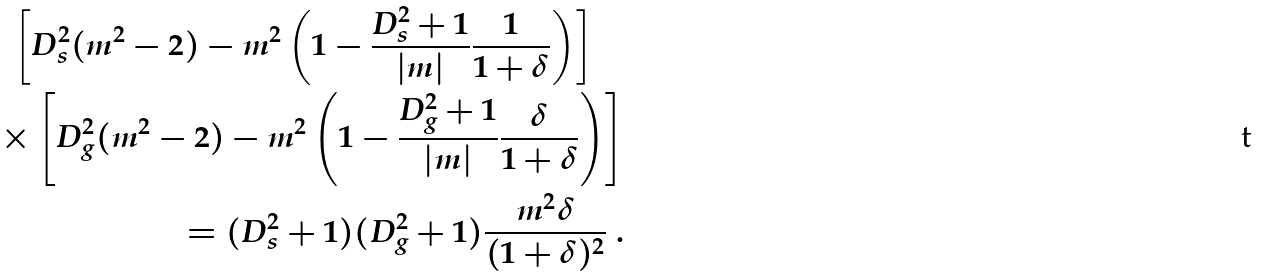<formula> <loc_0><loc_0><loc_500><loc_500>\left [ D _ { s } ^ { 2 } ( m ^ { 2 } - 2 ) - m ^ { 2 } \left ( 1 - \frac { D _ { s } ^ { 2 } + 1 } { | m | } \frac { 1 } { 1 + \delta } \right ) \right ] \quad \\ \times \left [ D _ { g } ^ { 2 } ( m ^ { 2 } - 2 ) - m ^ { 2 } \left ( 1 - \frac { D _ { g } ^ { 2 } + 1 } { | m | } \frac { \delta } { 1 + \delta } \right ) \right ] \\ = ( D _ { s } ^ { 2 } + 1 ) ( D _ { g } ^ { 2 } + 1 ) \frac { m ^ { 2 } \delta } { ( 1 + \delta ) ^ { 2 } } \ .</formula> 